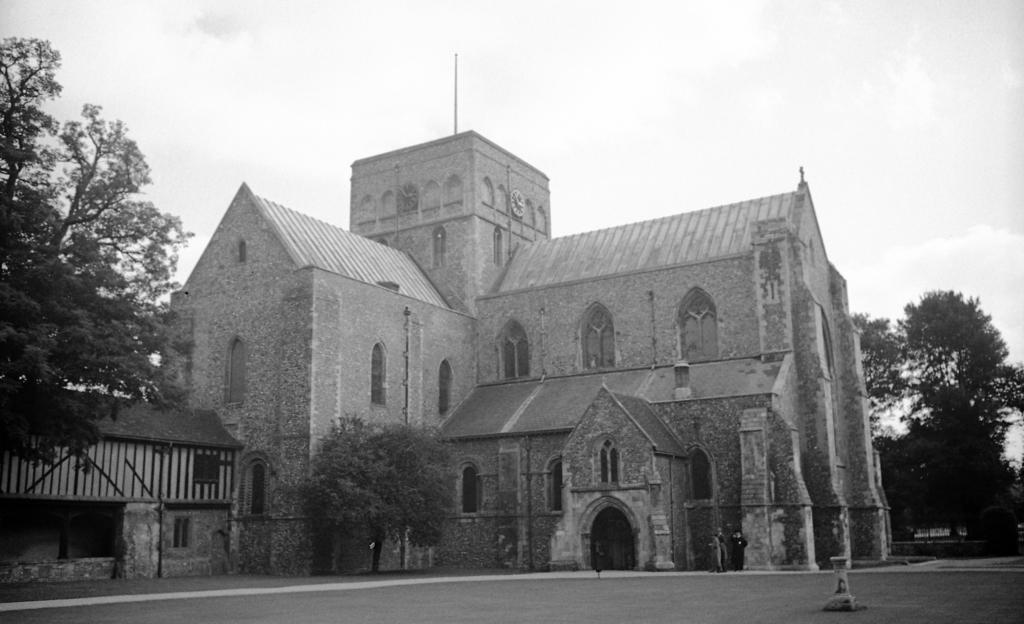What is the color scheme of the image? The image is black and white. What can be seen at the bottom of the image? There is a road at the bottom of the image. What type of structure is present in the image? There is a building in the image. What other natural elements can be seen in the image? There are trees in the image. What is visible at the top of the image? The sky is visible at the top of the image. How many geese are flying in the record in the image? There is no record or geese present in the image; it features a black and white scene with a road, building, trees, and sky. 